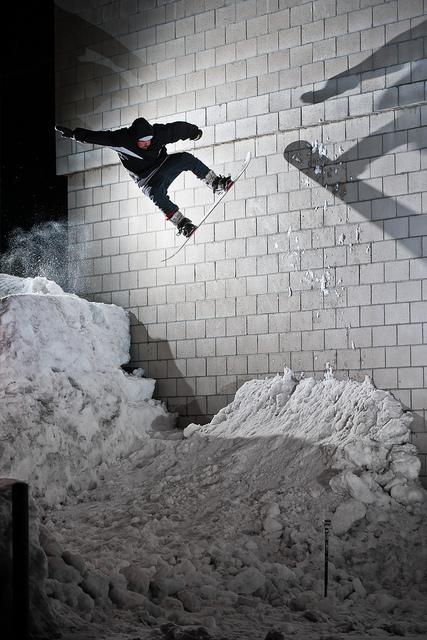What color is the snow?
Give a very brief answer. White. Is the man skiing?
Answer briefly. No. Is the snow covering the wall?
Keep it brief. No. Is the man going to crash into the wall?
Give a very brief answer. No. 